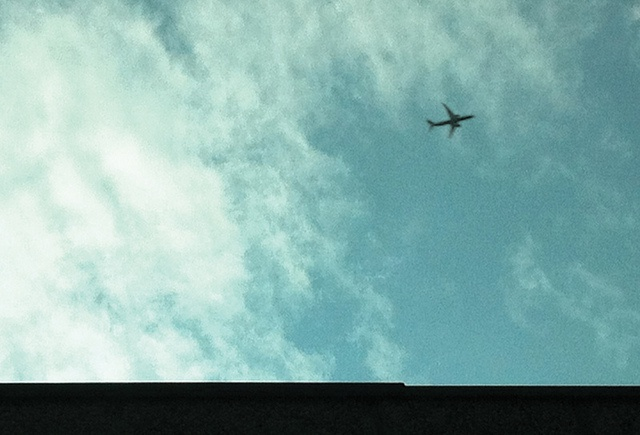Describe the objects in this image and their specific colors. I can see a airplane in lightblue, black, and teal tones in this image. 